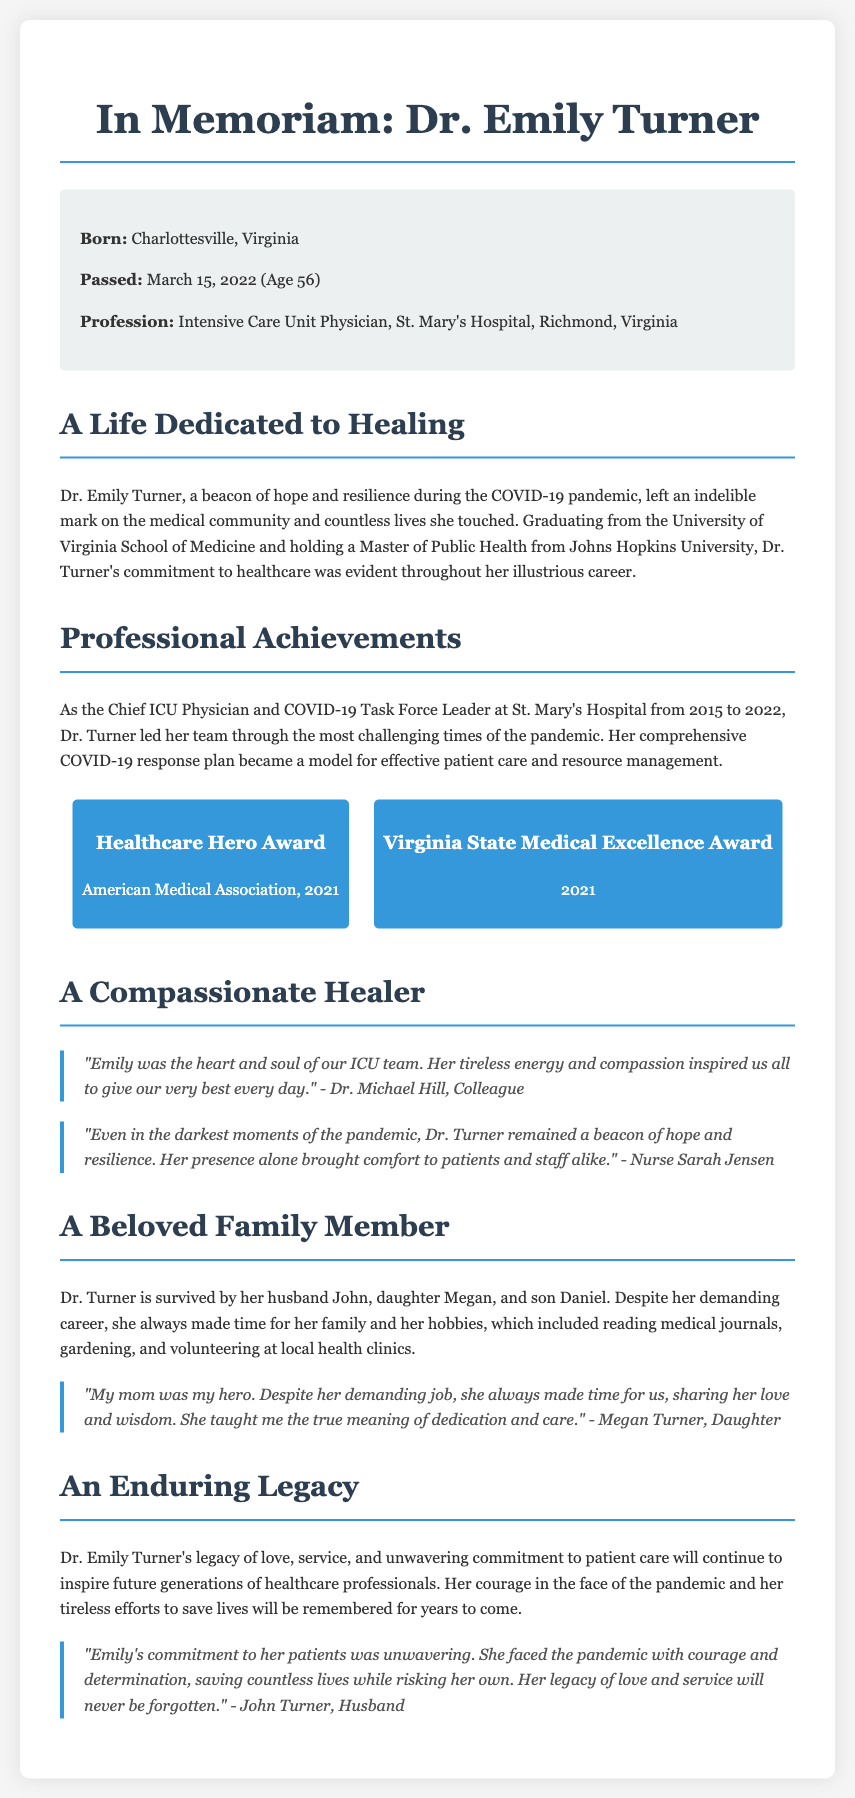What was Dr. Emily Turner’s profession? The document states that she was an Intensive Care Unit Physician.
Answer: Intensive Care Unit Physician When did Dr. Emily Turner pass away? The document mentions the date of her passing as March 15, 2022.
Answer: March 15, 2022 What age was she when she passed? The document indicates she was 56 years old at the time of her passing.
Answer: 56 Which hospital did Dr. Turner work at? The document specifies that she worked at St. Mary's Hospital.
Answer: St. Mary's Hospital What award did she receive from the American Medical Association? The document states she received the Healthcare Hero Award in 2021.
Answer: Healthcare Hero Award Who described Dr. Turner as "the heart and soul of our ICU team"? The document cites Dr. Michael Hill as the one who described her this way.
Answer: Dr. Michael Hill What was Dr. Turner's response plan during the pandemic recognized as? The document describes her COVID-19 response plan as a model for effective patient care and resource management.
Answer: A model for effective patient care and resource management Who is one of her surviving family members mentioned in the document? The document lists her husband John as one of her surviving family members.
Answer: John What did Dr. Turner enjoy doing outside of her job? The document mentions her hobbies included reading medical journals, gardening, and volunteering at local health clinics.
Answer: Reading medical journals, gardening, volunteering at local health clinics 